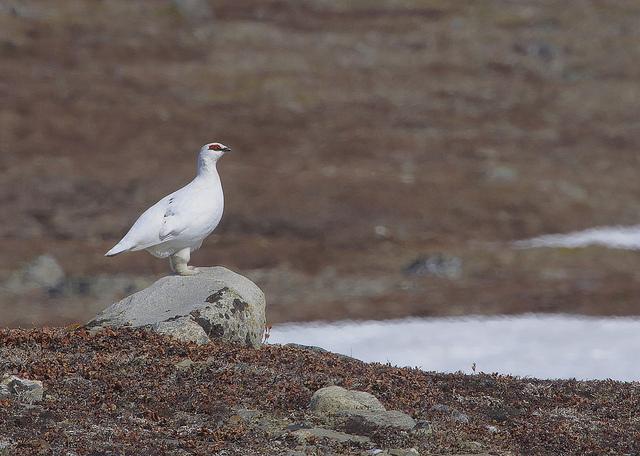What type of bird?
Answer briefly. Dove. How many birds are in the picture?
Give a very brief answer. 1. What is the bird sitting on?
Keep it brief. Rock. Where are the rocks?
Be succinct. On ground. Where is the bird standing in the picture?
Short answer required. Rock. What type of bird is this?
Concise answer only. Pigeon. How many birds are there?
Give a very brief answer. 1. What color is the bird?
Concise answer only. White. What color are the majority of the rocks?
Write a very short answer. Gray. How many eggs are visible?
Be succinct. 0. What is the bird standing on?
Answer briefly. Rock. What kind of bird is it?
Short answer required. Pigeon. What are the birds standing on?
Quick response, please. Rock. 